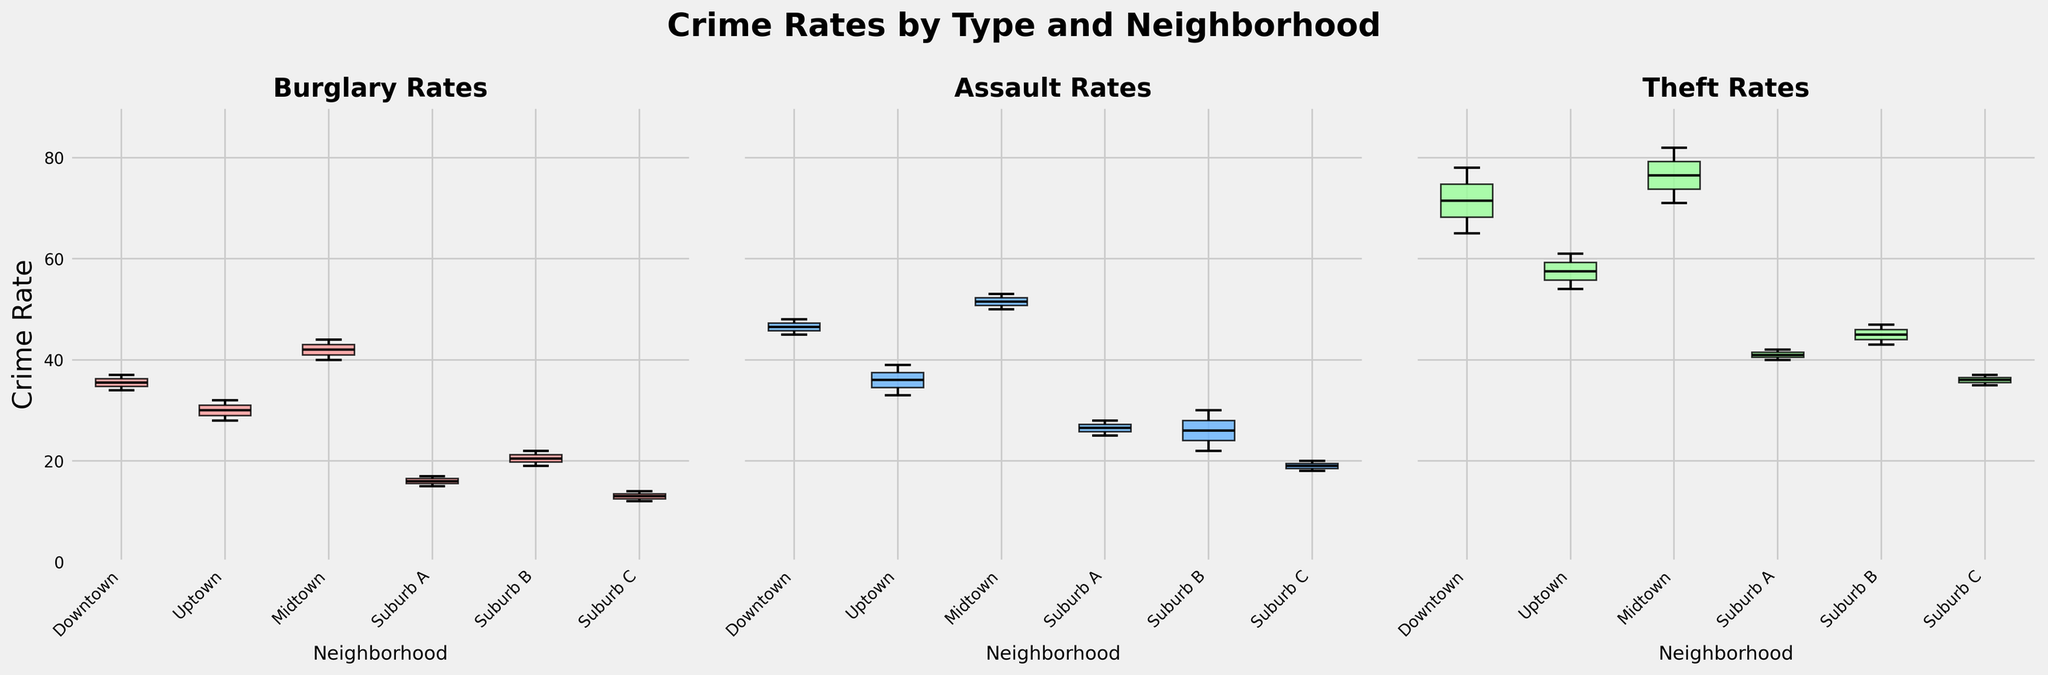What is the title of the figure? The title of the figure is displayed at the top of the plot and summarizes the content of the plots.
Answer: Crime Rates by Type and Neighborhood How many subplots are there in the figure? The figure contains three subplots arranged side by side.
Answer: 3 Which neighborhood has the highest median crime rate for Burglary? Look at the box plot for "Burglary Rates". The neighborhood with the highest central line (median) indicator is Midtown.
Answer: Midtown Does Downtown have a higher median crime rate for Assault or Theft? Compare the central line (median) indicators in the "Assault Rates" and "Theft Rates" subplots for Downtown. The Theft subplot shows a higher central line than the Assault plot.
Answer: Theft Which neighborhood shows the widest range of crime rates for Theft? Look at the box plot for "Theft Rates" and compare the lengths of the boxes and whiskers (range). Downtown has the widest range.
Answer: Downtown What is the approximate difference between the maximum crime rate in "Assault Rates" for Midtown and Uptown? In the "Assault Rates" subplot, locate the upper whisker (maximum) for Midtown and Uptown, and subtract Uptown's value from Midtown's value. The approximate difference is about 53 - 39.
Answer: 14 Which crime type has the lowest median rate in Suburb C? Look at Suburb C's boxes in the three subplots. The smallest central line (median) indicator is in the "Burglary Rates" subplot.
Answer: Burglary Is the difference in median crime rates between Suburb A and Suburb B for Assaults greater than for Burglaries? Compare the central line (median) indicators for Suburb A and Suburb B in both "Assault Rates" and "Burglary Rates" subplots. Calculate the differences (28-22 for Assaults, 17-19 for Burglaries). The difference is greater for Assaults.
Answer: Yes Which neighborhood has a more consistent crime rate for Theft, considering the interquartile range (IQR)? Consistency can be judged by the size of the box (IQR). Suburb A has a smaller IQR compared to others in the "Theft Rates" subplot.
Answer: Suburb A 